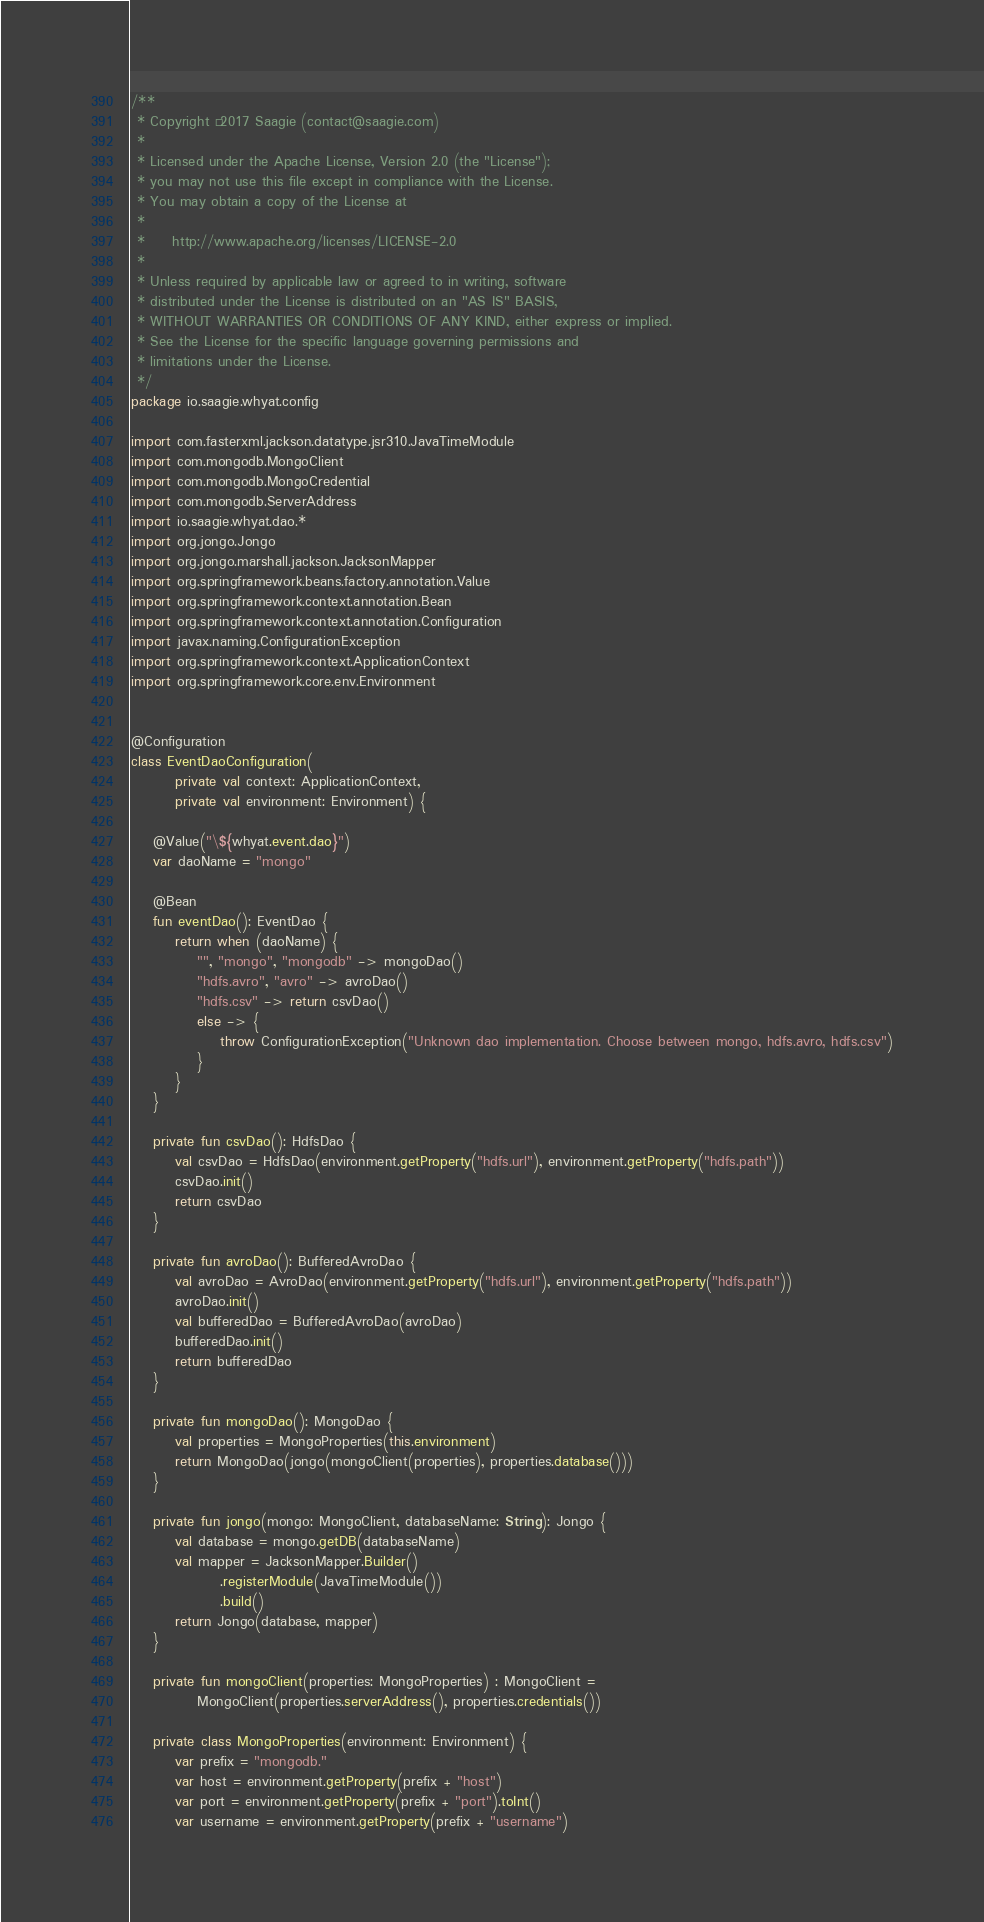Convert code to text. <code><loc_0><loc_0><loc_500><loc_500><_Kotlin_>/**
 * Copyright © 2017 Saagie (contact@saagie.com)
 *
 * Licensed under the Apache License, Version 2.0 (the "License");
 * you may not use this file except in compliance with the License.
 * You may obtain a copy of the License at
 *
 *     http://www.apache.org/licenses/LICENSE-2.0
 *
 * Unless required by applicable law or agreed to in writing, software
 * distributed under the License is distributed on an "AS IS" BASIS,
 * WITHOUT WARRANTIES OR CONDITIONS OF ANY KIND, either express or implied.
 * See the License for the specific language governing permissions and
 * limitations under the License.
 */
package io.saagie.whyat.config

import com.fasterxml.jackson.datatype.jsr310.JavaTimeModule
import com.mongodb.MongoClient
import com.mongodb.MongoCredential
import com.mongodb.ServerAddress
import io.saagie.whyat.dao.*
import org.jongo.Jongo
import org.jongo.marshall.jackson.JacksonMapper
import org.springframework.beans.factory.annotation.Value
import org.springframework.context.annotation.Bean
import org.springframework.context.annotation.Configuration
import javax.naming.ConfigurationException
import org.springframework.context.ApplicationContext
import org.springframework.core.env.Environment


@Configuration
class EventDaoConfiguration(
        private val context: ApplicationContext,
        private val environment: Environment) {

    @Value("\${whyat.event.dao}")
    var daoName = "mongo"

    @Bean
    fun eventDao(): EventDao {
        return when (daoName) {
            "", "mongo", "mongodb" -> mongoDao()
            "hdfs.avro", "avro" -> avroDao()
            "hdfs.csv" -> return csvDao()
            else -> {
                throw ConfigurationException("Unknown dao implementation. Choose between mongo, hdfs.avro, hdfs.csv")
            }
        }
    }

    private fun csvDao(): HdfsDao {
        val csvDao = HdfsDao(environment.getProperty("hdfs.url"), environment.getProperty("hdfs.path"))
        csvDao.init()
        return csvDao
    }

    private fun avroDao(): BufferedAvroDao {
        val avroDao = AvroDao(environment.getProperty("hdfs.url"), environment.getProperty("hdfs.path"))
        avroDao.init()
        val bufferedDao = BufferedAvroDao(avroDao)
        bufferedDao.init()
        return bufferedDao
    }

    private fun mongoDao(): MongoDao {
        val properties = MongoProperties(this.environment)
        return MongoDao(jongo(mongoClient(properties), properties.database()))
    }

    private fun jongo(mongo: MongoClient, databaseName: String): Jongo {
        val database = mongo.getDB(databaseName)
        val mapper = JacksonMapper.Builder()
                .registerModule(JavaTimeModule())
                .build()
        return Jongo(database, mapper)
    }

    private fun mongoClient(properties: MongoProperties) : MongoClient =
            MongoClient(properties.serverAddress(), properties.credentials())

    private class MongoProperties(environment: Environment) {
        var prefix = "mongodb."
        var host = environment.getProperty(prefix + "host")
        var port = environment.getProperty(prefix + "port").toInt()
        var username = environment.getProperty(prefix + "username")</code> 